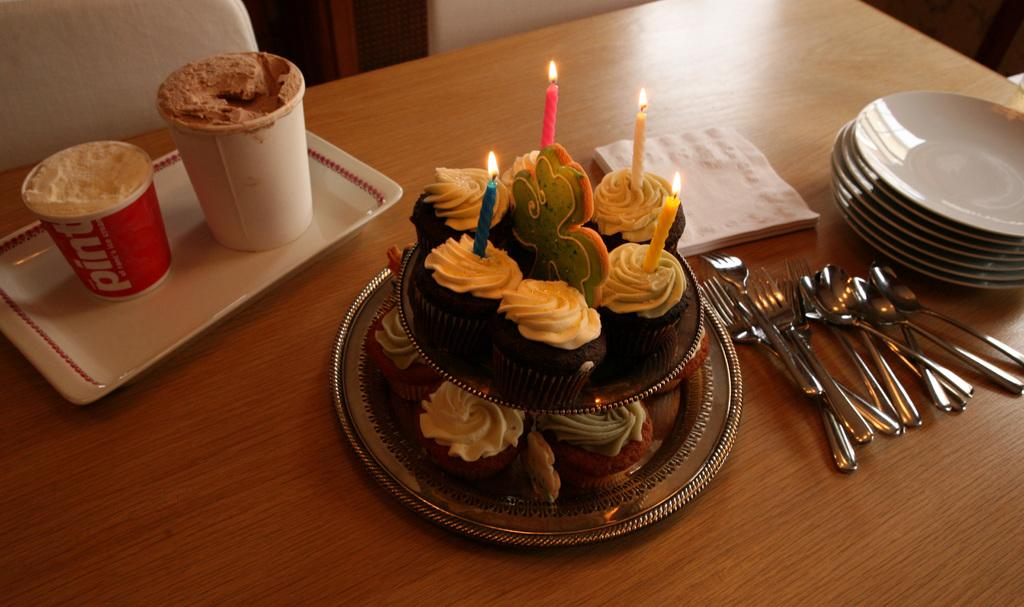What is the main piece of furniture in the image? There is a table in the image. What is placed on the table? There is a cake, candles, tissues, plates, and phones on the table. What is the purpose of the candles on the table? The candles on the table are likely for decoration or to be lit during a celebration. What is the seating arrangement in the image? There is a chair in the image. What type of tent can be seen in the image? There is no tent present in the image. What angle is the dirt visible from in the image? There is no dirt visible in the image. 